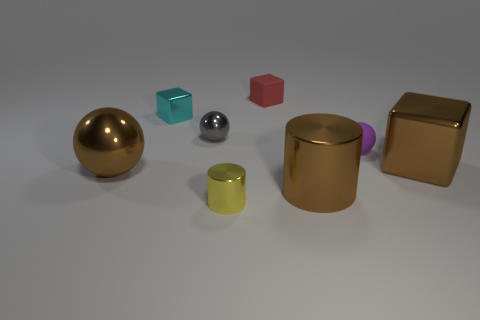Subtract all brown shiny balls. How many balls are left? 2 Subtract all brown blocks. How many blocks are left? 2 Add 2 large green metal balls. How many objects exist? 10 Subtract all green cylinders. How many purple balls are left? 1 Subtract all yellow cylinders. Subtract all blue blocks. How many cylinders are left? 1 Subtract all small purple objects. Subtract all brown shiny spheres. How many objects are left? 6 Add 6 tiny spheres. How many tiny spheres are left? 8 Add 5 tiny gray spheres. How many tiny gray spheres exist? 6 Subtract 0 gray cylinders. How many objects are left? 8 Subtract all balls. How many objects are left? 5 